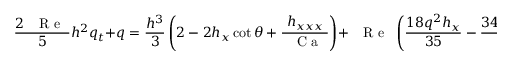<formula> <loc_0><loc_0><loc_500><loc_500>\frac { 2 { R e } } { 5 } h ^ { 2 } q _ { t } + q = \frac { h ^ { 3 } } { 3 } \left ( 2 - 2 h _ { x } \cot \theta + \frac { h _ { x x x } } { { C a } } \right ) + { R e } \left ( \frac { 1 8 q ^ { 2 } h _ { x } } { 3 5 } - \frac { 3 4 h q q _ { x } } { 3 5 } + \frac { h q f } { 5 } \right ) ,</formula> 